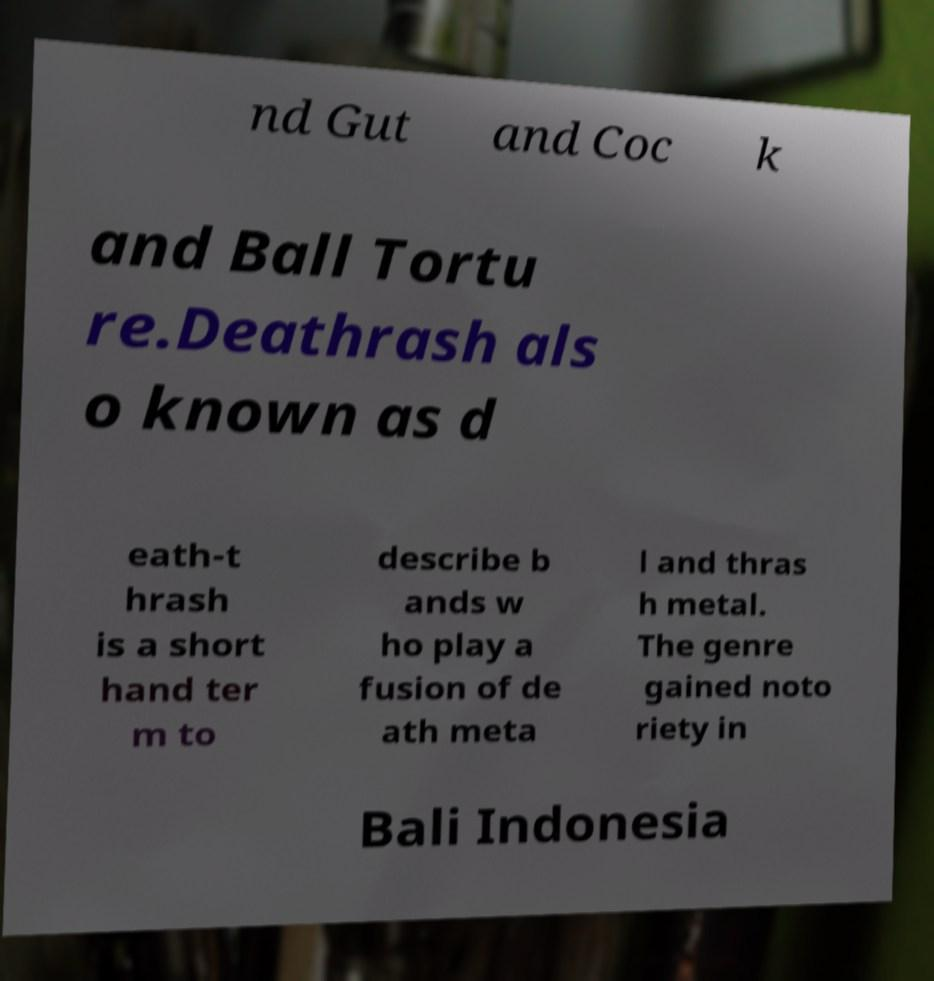I need the written content from this picture converted into text. Can you do that? nd Gut and Coc k and Ball Tortu re.Deathrash als o known as d eath-t hrash is a short hand ter m to describe b ands w ho play a fusion of de ath meta l and thras h metal. The genre gained noto riety in Bali Indonesia 